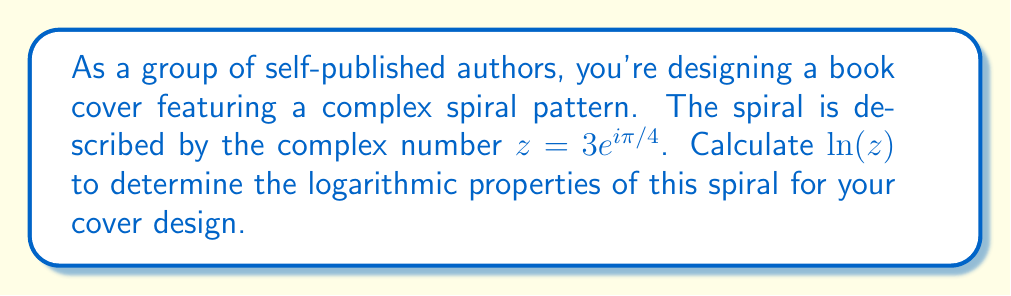Show me your answer to this math problem. To compute the logarithm of a complex number $z = re^{i\theta}$, we use the formula:

$$\ln(z) = \ln(r) + i\theta$$

Where $r$ is the modulus and $\theta$ is the argument of the complex number.

Step 1: Identify the modulus and argument of $z = 3e^{i\pi/4}$
- Modulus: $r = 3$
- Argument: $\theta = \pi/4$

Step 2: Apply the formula
$$\ln(z) = \ln(3) + i(\pi/4)$$

Step 3: Simplify
The natural logarithm of 3 cannot be simplified further, so we leave it as $\ln(3)$.

Therefore, the final result is:
$$\ln(z) = \ln(3) + i\pi/4$$
Answer: $\ln(3) + i\pi/4$ 